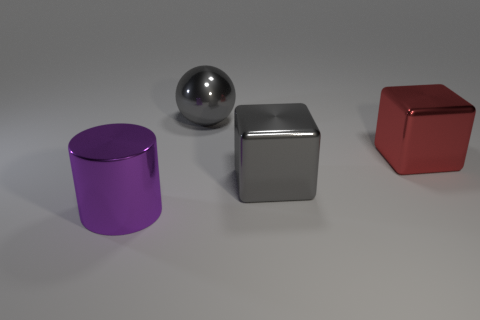Add 3 big purple metallic objects. How many objects exist? 7 Subtract 2 blocks. How many blocks are left? 0 Subtract all cylinders. How many objects are left? 3 Add 1 gray shiny balls. How many gray shiny balls exist? 2 Subtract 0 blue cylinders. How many objects are left? 4 Subtract all cyan balls. Subtract all gray blocks. How many balls are left? 1 Subtract all green cylinders. How many green balls are left? 0 Subtract all purple metal things. Subtract all big red metal things. How many objects are left? 2 Add 3 gray spheres. How many gray spheres are left? 4 